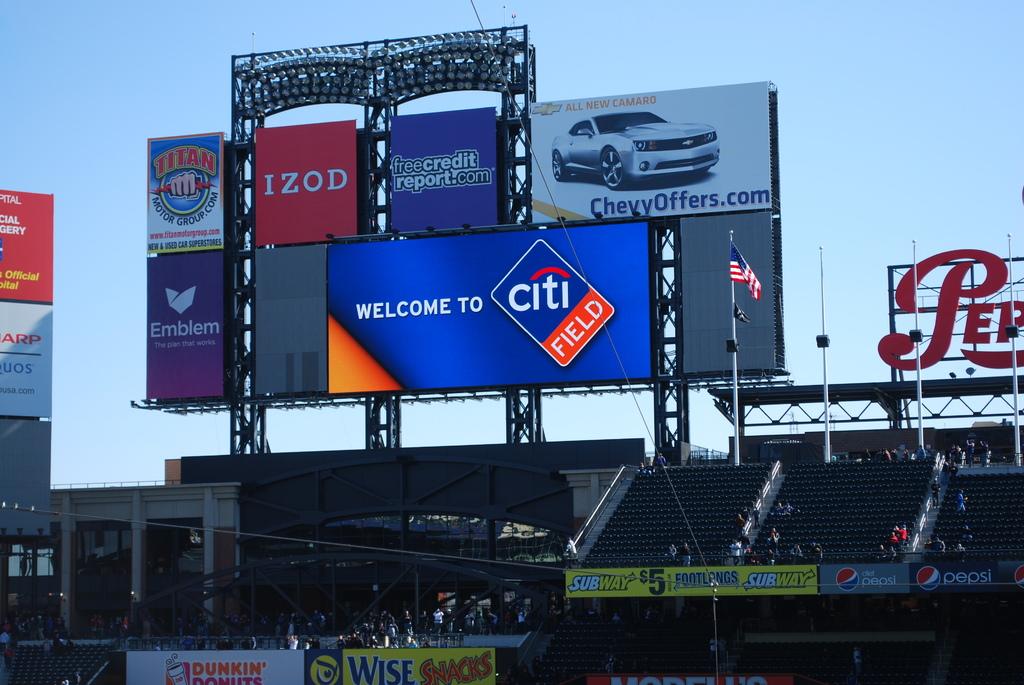What stadium is the game taking place?
Your answer should be very brief. Citi field. What credit company is a sponsor?
Your answer should be very brief. Citi. 